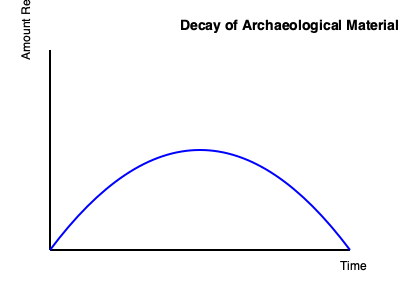As a historian collaborating with a chemical analyst, you're studying the decay rate of an organic archaeological material. The graph shows an exponential decay curve. If the half-life of this material is 500 years, what percentage of the original amount will remain after 1500 years? To solve this problem, we need to follow these steps:

1. Understand the concept of half-life: It's the time required for half of the substance to decay.

2. Identify the number of half-lives that have passed:
   Time passed = 1500 years
   Half-life = 500 years
   Number of half-lives = 1500 / 500 = 3

3. Calculate the remaining fraction after each half-life:
   After 1 half-life: 1/2 of the original amount
   After 2 half-lives: 1/2 × 1/2 = 1/4 of the original amount
   After 3 half-lives: 1/2 × 1/2 × 1/2 = 1/8 of the original amount

4. Convert the fraction to a percentage:
   1/8 = 0.125
   0.125 × 100 = 12.5%

Therefore, after 1500 years, 12.5% of the original amount of the archaeological material will remain.
Answer: 12.5% 